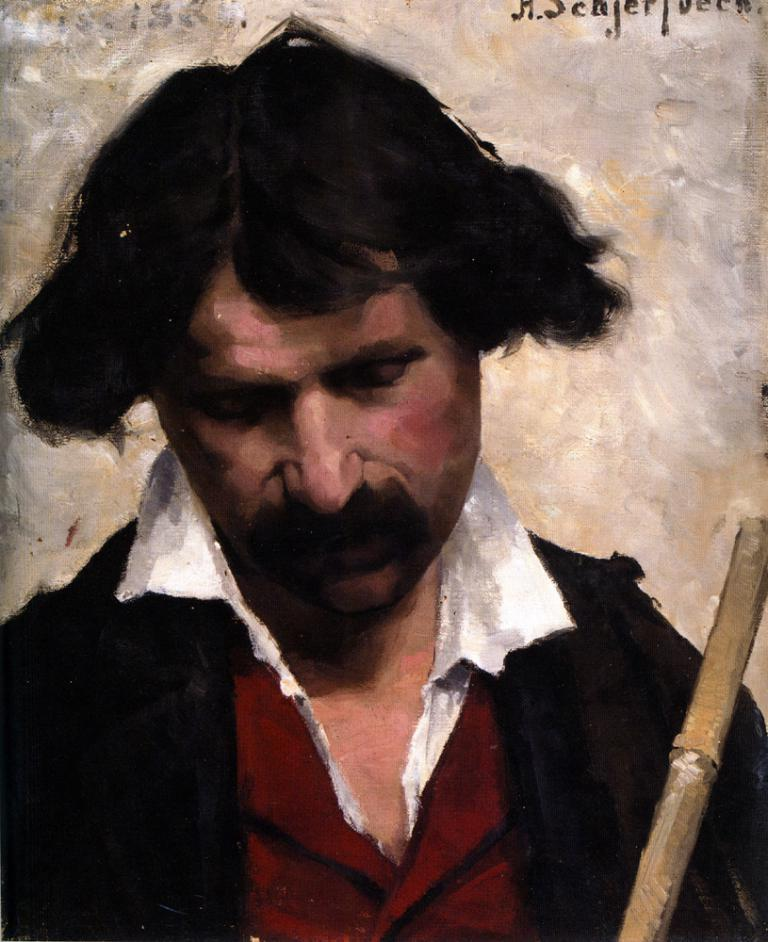What is depicted in the image? There is a painting of a man in the image. What is the man wearing in the painting? The man is wearing a black color shirt. Where is the stick located in the image? The stick is in the right corner of the image. What color is the background of the image? The background of the image is white. Can you describe the waves in the image? There are no waves present in the image. The image features a painting of a man and a stick in the right corner, with a white background. 